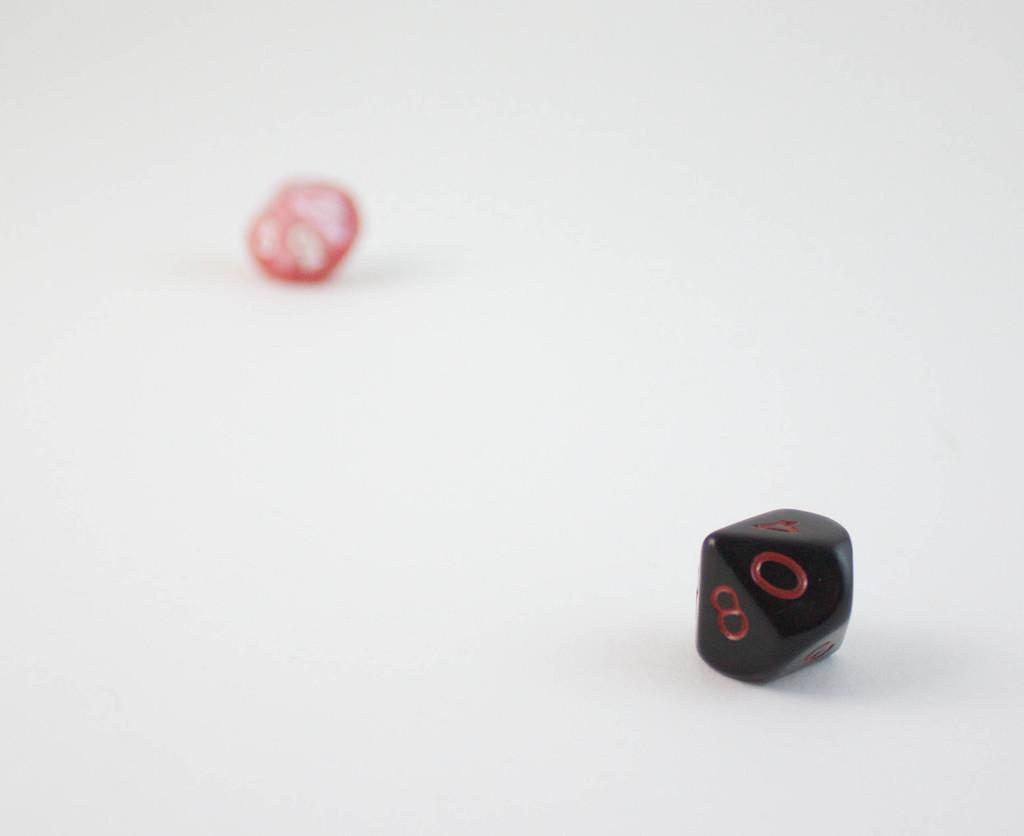How many objects can be seen in the image? There are two objects in the image. What is the color of the surface on which the objects are placed? The objects are on a white surface. What type of rhythm can be heard coming from the objects in the image? There is no sound or rhythm associated with the objects in the image. What sense is being stimulated by the objects in the image? The image is visual, so the sense being stimulated is sight. However, there is no indication of any other senses being stimulated by the objects in the image. 